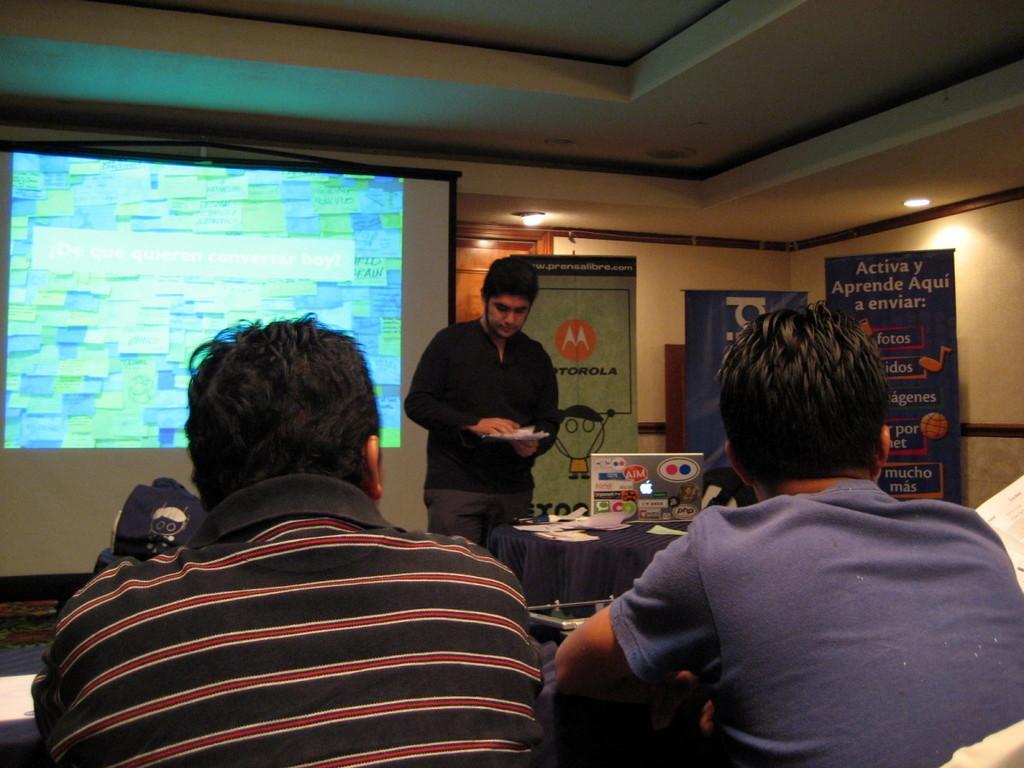Can you describe this image briefly? At the top we can see the ceiling and lights. In the background we can see the screen, wooden door, banners. We can see a man is holding papers in his hands and standing near to a table. On the table we can see a laptop and papers. At the bottom portion of the picture we can see people. 